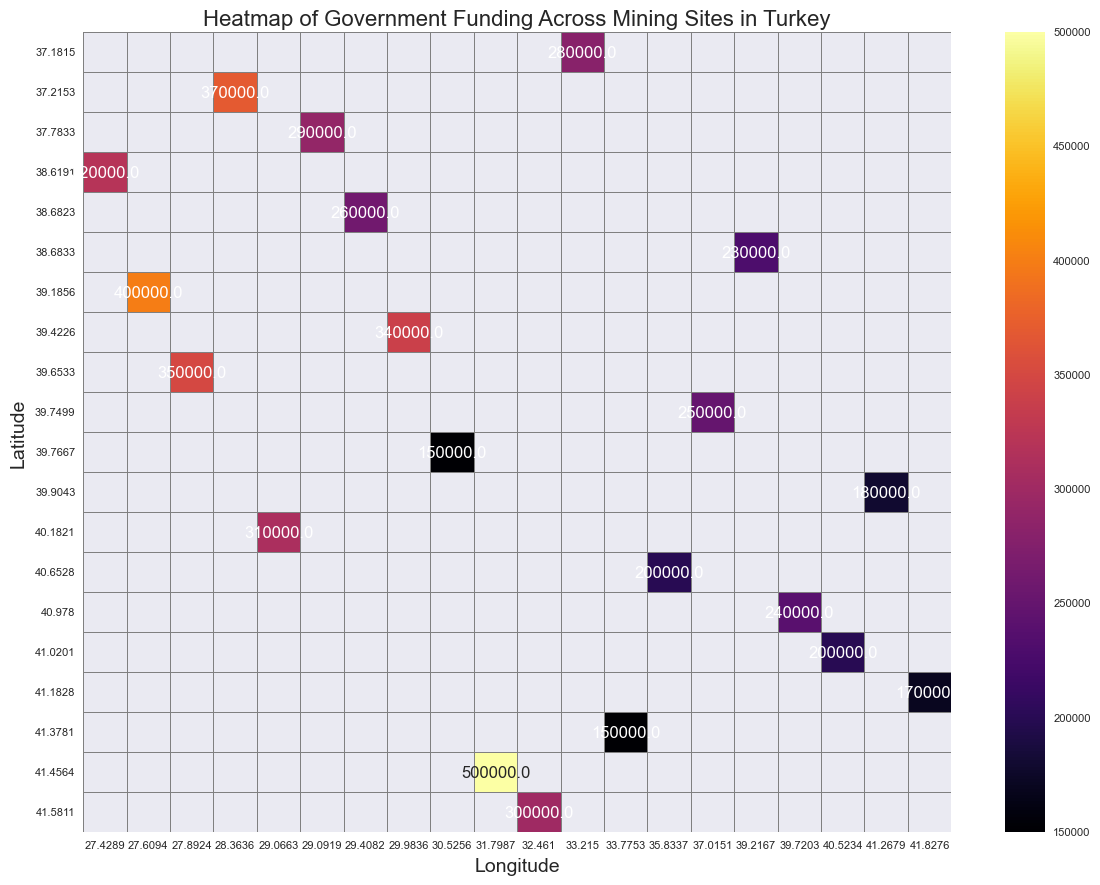Which mining site received the highest funding? Looking at the heatmap, search for the site with the highest numerical value for funding.
Answer: Zonguldak Which site had more inspections, Soma or Denizli? Compare the number of inspections for Soma and Denizli from their respective values. Soma had 12 inspections, while Denizli had 7.
Answer: Soma What is the difference in funding between Bartin and Amasya? Locate the funding values for Bartin (300,000) and Amasya (200,000). Subtract Amasya's funding from Bartin's funding: 300,000 - 200,000 = 100,000.
Answer: 100,000 Which site located at Latitude 41.4564 and Longitude 31.7987? Match the provided coordinates to the respective row and column, which corresponds to Zonguldak.
Answer: Zonguldak How many mining sites received funding greater than 300,000? Identify and count the heatmap cells with funding values greater than 300,000. These sites are Zonguldak, Soma, Mugla, Balikesir, Kütahya.
Answer: 5 Which has higher funding, Trabzon or Rize? Compare the funding values for Trabzon (240,000) and Rize (200,000).
Answer: Trabzon What is the average funding for sites that had exactly 5 inspections? Identify the funding values for sites with 5 inspections (Amasya - 200,000, Elazig - 230,000, Rize - 200,000). Calculate the average: (200,000 + 230,000 + 200,000) / 3 = 210,000.
Answer: 210,000 What color represents the higher funding amounts in the heatmap? Observe the color gradient used in the heatmap. The darker shades closer to red indicate higher funding amounts.
Answer: Red Which mining sites are located geographically closer to each other in the heatmap? Visually identify clusters or groups of sites that are close together in the heatmap based on latitude and longitude. Zonguldak and Bartin are geographically closer.
Answer: Zonguldak and Bartin What is the trend in inspections and funding allocations, does higher funding correlate to more inspections? Compare the values for inspections and funding across different sites, noting that Zonguldak (highest funding) had the highest inspections, indicating a possible trend.
Answer: Yes 